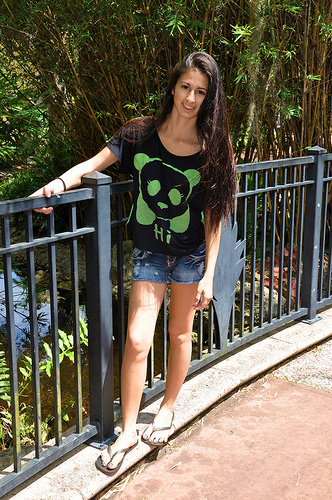<image>
Is the girl next to the floor? Yes. The girl is positioned adjacent to the floor, located nearby in the same general area. 